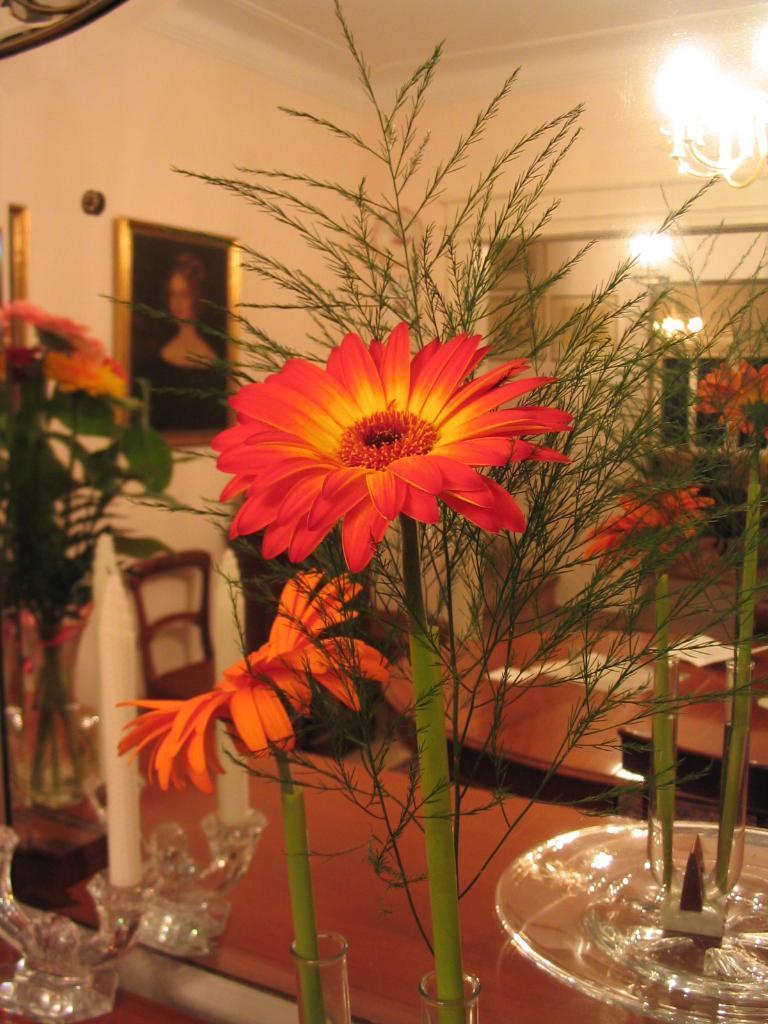How would you summarize this image in a sentence or two? This flowers is highlighted in this picture. A picture on a wall. On top there is a light. On this table there is a candle and flower vase. Far there is a chair. 